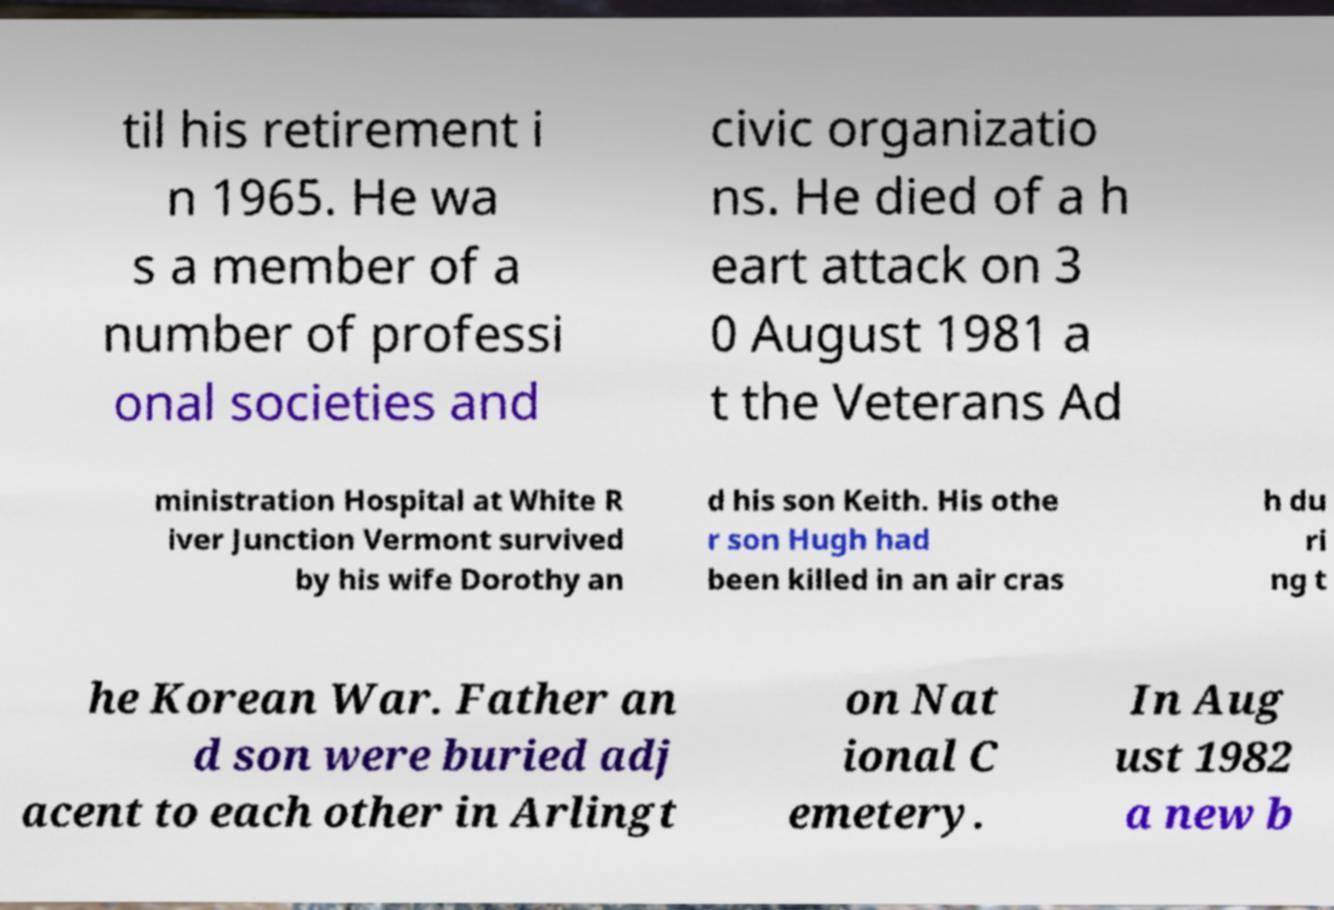What messages or text are displayed in this image? I need them in a readable, typed format. til his retirement i n 1965. He wa s a member of a number of professi onal societies and civic organizatio ns. He died of a h eart attack on 3 0 August 1981 a t the Veterans Ad ministration Hospital at White R iver Junction Vermont survived by his wife Dorothy an d his son Keith. His othe r son Hugh had been killed in an air cras h du ri ng t he Korean War. Father an d son were buried adj acent to each other in Arlingt on Nat ional C emetery. In Aug ust 1982 a new b 